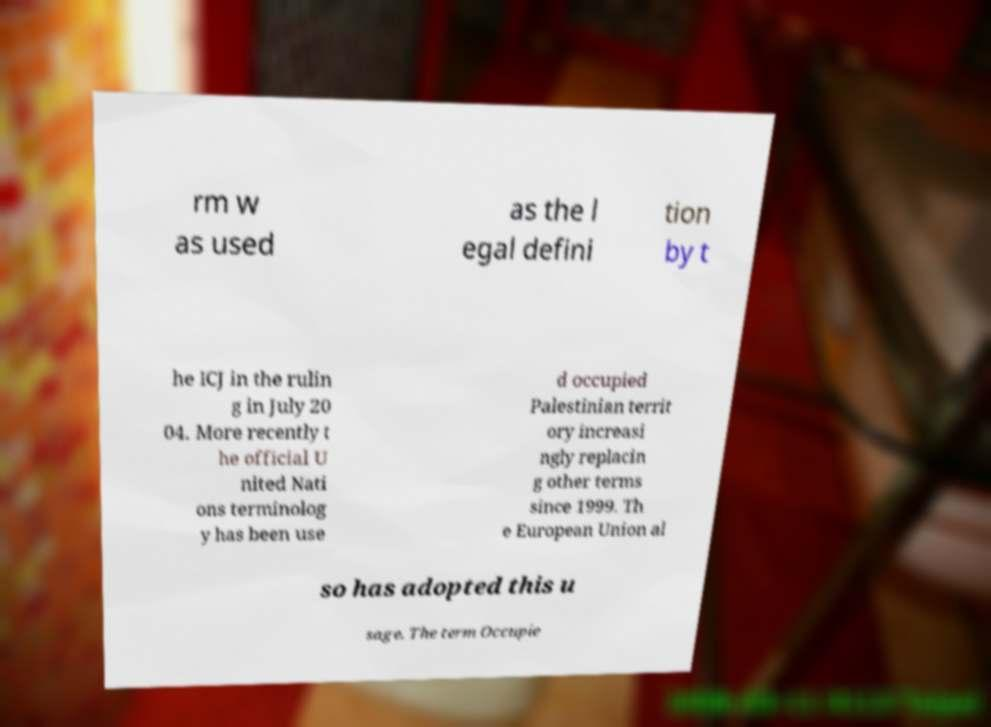Can you read and provide the text displayed in the image?This photo seems to have some interesting text. Can you extract and type it out for me? rm w as used as the l egal defini tion by t he ICJ in the rulin g in July 20 04. More recently t he official U nited Nati ons terminolog y has been use d occupied Palestinian territ ory increasi ngly replacin g other terms since 1999. Th e European Union al so has adopted this u sage. The term Occupie 